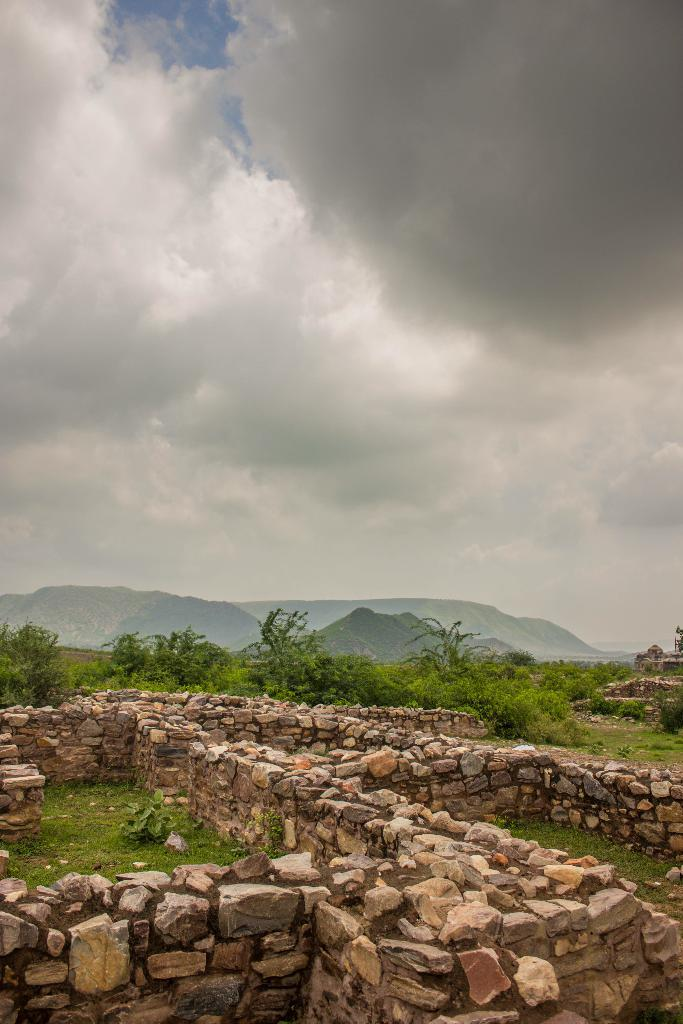What is the setting of the image? The image is an outside view. What can be seen at the bottom of the image? There are walls at the bottom of the image. What type of natural features are visible in the background of the image? There are many trees and hills in the background of the image. What is visible at the top of the image? The sky is visible at the top of the image. What can be observed in the sky? Clouds are present in the sky. What position does the caption hold in the image? There is no caption present in the image. How many legs can be seen on the trees in the image? Trees do not have legs; they have trunks and branches. 